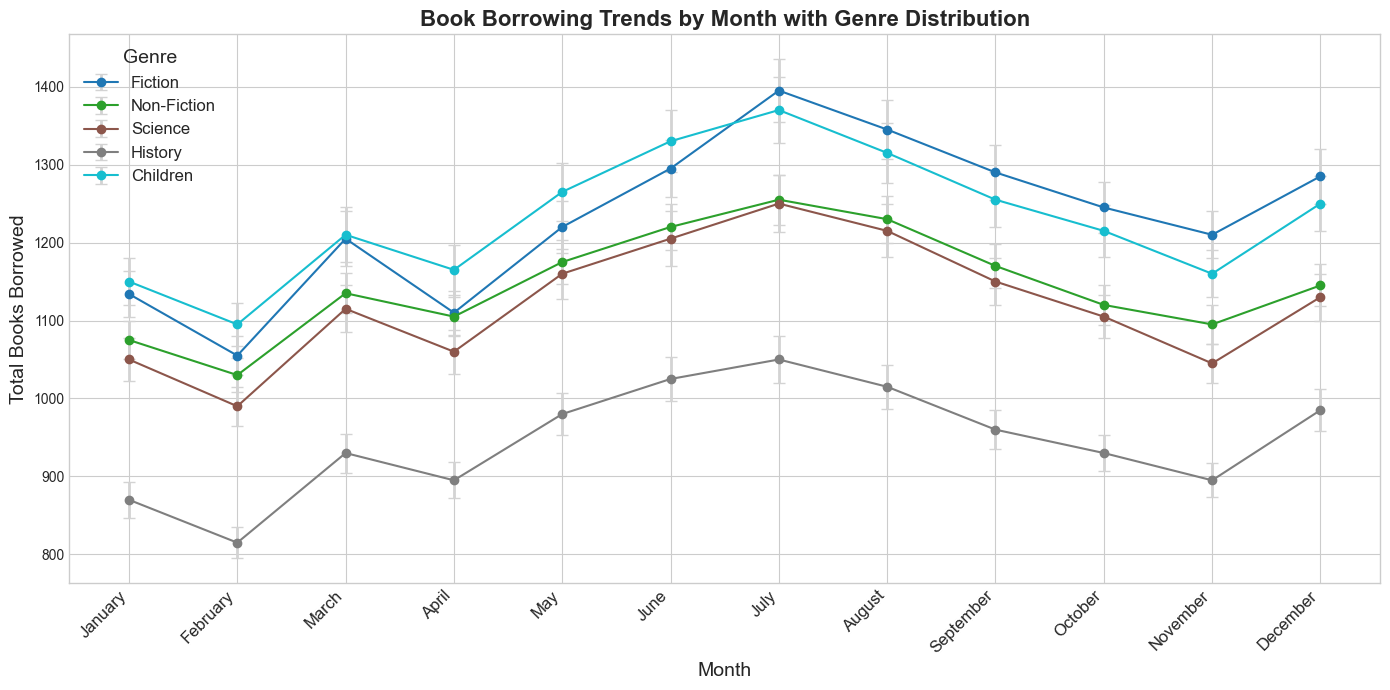Which genre has the highest total book borrowings in July? Look at the data points marked for July across the different genres and identify the highest data point. The genre Science has the highest total borrowings in July, with approximately 1370 books borrowed.
Answer: Science What is the difference in the total borrowings between Fiction in December and Children in December? In December, Fiction has a total borrowing of 1285 books, and Children has 1250. Subtract the lower value from the higher value: 1285 - 1250 = 35.
Answer: 35 Which month saw the lowest book borrowings in the History genre? Examine the history data points for each month. February has the lowest total borrowings in the History genre, approximately 815 books.
Answer: February How does the error for the Science genre in June compare to the Non-Fiction genre in June? In June, the Science genre has an error of 35, while Non-Fiction has an error of 30. Compare these values to find that the Science genre has a larger error.
Answer: Science has a larger error What is the total borrowing trend for the Fiction genre from January to December? Examine the Fiction data points from January to December and observe the overall trend. The total borrowings start around 1134 in January and fluctuate, with an overall increasing trend till July (1395), then decreasing slightly towards December (1285).
Answer: Increasing, then decreasing How much is the average total book borrowings for Science from May to August? To calculate the average, sum the total borrowings for Science from May to August: 1160 (May) + 1205 (June) + 1250 (July) + 1215 (August) = 4830. Divide this by 4: 4830 / 4 = 1207.5.
Answer: 1207.5 Which genre shows the most consistent borrowing trend across the months, considering the error bars? Look at the error bars for each genre across the months and evaluate their consistency. Use the genres' error-bar consistency and total borrowing trends to determine the answer. Non-Fiction shows relatively consistent borrowing trends through the months with smaller error bars compared to other genres.
Answer: Non-Fiction What is the significance of error bars in this chart? Error bars indicate the variability or uncertainty in the number of total books borrowed for each genre each month. They help understand how much the actual data point might deviate due to factors like incorrect borrowing records or inconsistent data reporting.
Answer: Variability of data 